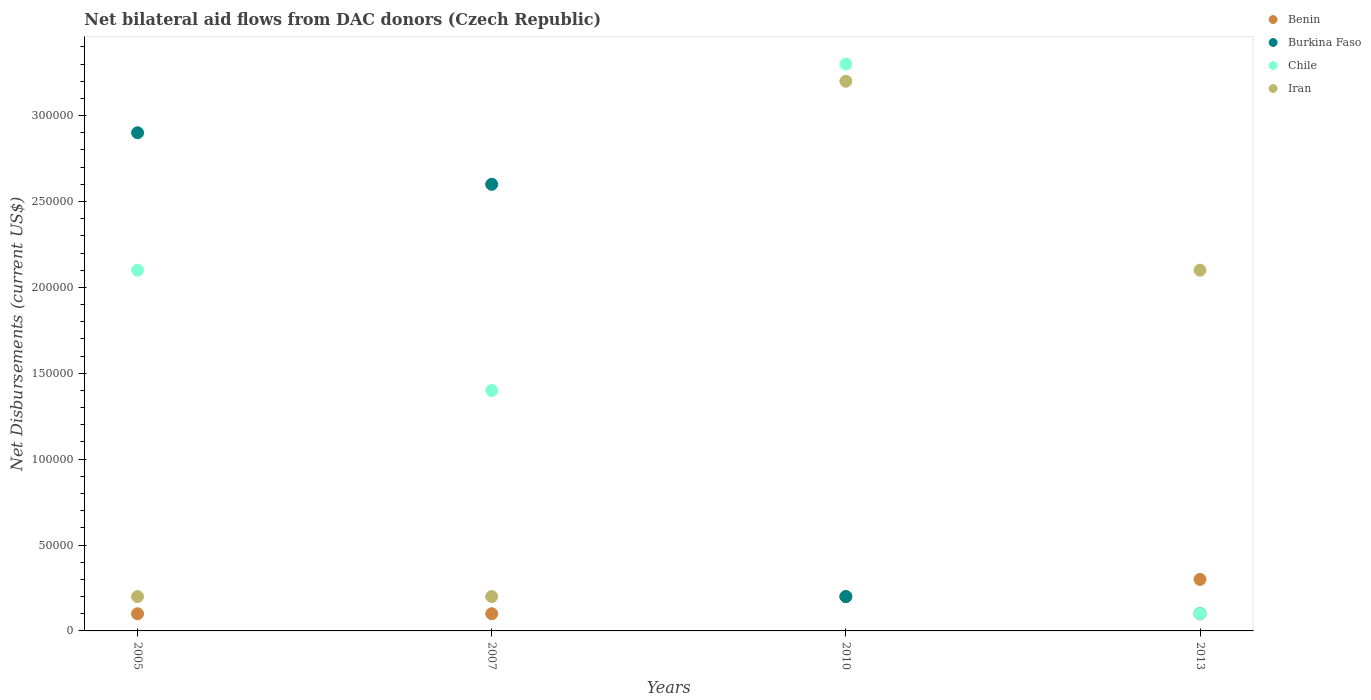How many different coloured dotlines are there?
Your answer should be compact. 4. Is the number of dotlines equal to the number of legend labels?
Keep it short and to the point. Yes. Across all years, what is the maximum net bilateral aid flows in Burkina Faso?
Offer a very short reply. 2.90e+05. Across all years, what is the minimum net bilateral aid flows in Iran?
Give a very brief answer. 2.00e+04. In which year was the net bilateral aid flows in Benin minimum?
Offer a terse response. 2005. What is the total net bilateral aid flows in Iran in the graph?
Your response must be concise. 5.70e+05. What is the difference between the net bilateral aid flows in Burkina Faso in 2013 and the net bilateral aid flows in Chile in 2005?
Ensure brevity in your answer.  -2.00e+05. What is the average net bilateral aid flows in Iran per year?
Your response must be concise. 1.42e+05. In the year 2005, what is the difference between the net bilateral aid flows in Iran and net bilateral aid flows in Burkina Faso?
Keep it short and to the point. -2.70e+05. What is the ratio of the net bilateral aid flows in Benin in 2007 to that in 2013?
Your response must be concise. 0.33. Is the net bilateral aid flows in Chile in 2005 less than that in 2007?
Make the answer very short. No. What is the difference between the highest and the second highest net bilateral aid flows in Iran?
Provide a short and direct response. 1.10e+05. In how many years, is the net bilateral aid flows in Chile greater than the average net bilateral aid flows in Chile taken over all years?
Your answer should be compact. 2. Is the sum of the net bilateral aid flows in Benin in 2007 and 2010 greater than the maximum net bilateral aid flows in Chile across all years?
Give a very brief answer. No. Is it the case that in every year, the sum of the net bilateral aid flows in Iran and net bilateral aid flows in Chile  is greater than the sum of net bilateral aid flows in Burkina Faso and net bilateral aid flows in Benin?
Give a very brief answer. No. Is the net bilateral aid flows in Benin strictly less than the net bilateral aid flows in Burkina Faso over the years?
Provide a succinct answer. No. How many years are there in the graph?
Provide a succinct answer. 4. What is the title of the graph?
Keep it short and to the point. Net bilateral aid flows from DAC donors (Czech Republic). What is the label or title of the Y-axis?
Provide a short and direct response. Net Disbursements (current US$). What is the Net Disbursements (current US$) in Burkina Faso in 2005?
Provide a short and direct response. 2.90e+05. What is the Net Disbursements (current US$) of Chile in 2005?
Provide a succinct answer. 2.10e+05. What is the Net Disbursements (current US$) of Benin in 2010?
Ensure brevity in your answer.  2.00e+04. What is the Net Disbursements (current US$) in Chile in 2010?
Keep it short and to the point. 3.30e+05. What is the Net Disbursements (current US$) in Iran in 2010?
Ensure brevity in your answer.  3.20e+05. What is the Net Disbursements (current US$) in Burkina Faso in 2013?
Offer a terse response. 10000. Across all years, what is the maximum Net Disbursements (current US$) in Iran?
Offer a terse response. 3.20e+05. Across all years, what is the minimum Net Disbursements (current US$) in Burkina Faso?
Offer a terse response. 10000. What is the total Net Disbursements (current US$) in Burkina Faso in the graph?
Make the answer very short. 5.80e+05. What is the total Net Disbursements (current US$) of Chile in the graph?
Your response must be concise. 6.90e+05. What is the total Net Disbursements (current US$) in Iran in the graph?
Give a very brief answer. 5.70e+05. What is the difference between the Net Disbursements (current US$) in Benin in 2005 and that in 2007?
Provide a succinct answer. 0. What is the difference between the Net Disbursements (current US$) in Chile in 2005 and that in 2007?
Provide a short and direct response. 7.00e+04. What is the difference between the Net Disbursements (current US$) in Benin in 2005 and that in 2010?
Keep it short and to the point. -10000. What is the difference between the Net Disbursements (current US$) in Iran in 2005 and that in 2010?
Your answer should be compact. -3.00e+05. What is the difference between the Net Disbursements (current US$) in Benin in 2005 and that in 2013?
Your answer should be compact. -2.00e+04. What is the difference between the Net Disbursements (current US$) of Iran in 2005 and that in 2013?
Give a very brief answer. -1.90e+05. What is the difference between the Net Disbursements (current US$) in Chile in 2007 and that in 2010?
Make the answer very short. -1.90e+05. What is the difference between the Net Disbursements (current US$) of Iran in 2007 and that in 2013?
Give a very brief answer. -1.90e+05. What is the difference between the Net Disbursements (current US$) of Benin in 2010 and that in 2013?
Your answer should be very brief. -10000. What is the difference between the Net Disbursements (current US$) in Chile in 2010 and that in 2013?
Provide a succinct answer. 3.20e+05. What is the difference between the Net Disbursements (current US$) of Iran in 2010 and that in 2013?
Give a very brief answer. 1.10e+05. What is the difference between the Net Disbursements (current US$) of Benin in 2005 and the Net Disbursements (current US$) of Burkina Faso in 2007?
Your response must be concise. -2.50e+05. What is the difference between the Net Disbursements (current US$) of Benin in 2005 and the Net Disbursements (current US$) of Chile in 2007?
Your answer should be very brief. -1.30e+05. What is the difference between the Net Disbursements (current US$) of Benin in 2005 and the Net Disbursements (current US$) of Iran in 2007?
Your answer should be very brief. -10000. What is the difference between the Net Disbursements (current US$) of Burkina Faso in 2005 and the Net Disbursements (current US$) of Iran in 2007?
Keep it short and to the point. 2.70e+05. What is the difference between the Net Disbursements (current US$) in Benin in 2005 and the Net Disbursements (current US$) in Chile in 2010?
Your answer should be very brief. -3.20e+05. What is the difference between the Net Disbursements (current US$) of Benin in 2005 and the Net Disbursements (current US$) of Iran in 2010?
Provide a short and direct response. -3.10e+05. What is the difference between the Net Disbursements (current US$) in Burkina Faso in 2005 and the Net Disbursements (current US$) in Iran in 2010?
Offer a very short reply. -3.00e+04. What is the difference between the Net Disbursements (current US$) of Benin in 2005 and the Net Disbursements (current US$) of Chile in 2013?
Your answer should be very brief. 0. What is the difference between the Net Disbursements (current US$) of Burkina Faso in 2005 and the Net Disbursements (current US$) of Iran in 2013?
Your answer should be compact. 8.00e+04. What is the difference between the Net Disbursements (current US$) of Chile in 2005 and the Net Disbursements (current US$) of Iran in 2013?
Your answer should be very brief. 0. What is the difference between the Net Disbursements (current US$) of Benin in 2007 and the Net Disbursements (current US$) of Chile in 2010?
Your response must be concise. -3.20e+05. What is the difference between the Net Disbursements (current US$) of Benin in 2007 and the Net Disbursements (current US$) of Iran in 2010?
Your response must be concise. -3.10e+05. What is the difference between the Net Disbursements (current US$) of Burkina Faso in 2007 and the Net Disbursements (current US$) of Chile in 2010?
Keep it short and to the point. -7.00e+04. What is the difference between the Net Disbursements (current US$) in Burkina Faso in 2007 and the Net Disbursements (current US$) in Iran in 2010?
Offer a terse response. -6.00e+04. What is the difference between the Net Disbursements (current US$) in Chile in 2007 and the Net Disbursements (current US$) in Iran in 2010?
Your answer should be very brief. -1.80e+05. What is the difference between the Net Disbursements (current US$) of Benin in 2007 and the Net Disbursements (current US$) of Chile in 2013?
Your answer should be compact. 0. What is the difference between the Net Disbursements (current US$) in Benin in 2007 and the Net Disbursements (current US$) in Iran in 2013?
Provide a short and direct response. -2.00e+05. What is the difference between the Net Disbursements (current US$) of Burkina Faso in 2007 and the Net Disbursements (current US$) of Chile in 2013?
Offer a terse response. 2.50e+05. What is the difference between the Net Disbursements (current US$) in Burkina Faso in 2007 and the Net Disbursements (current US$) in Iran in 2013?
Offer a terse response. 5.00e+04. What is the difference between the Net Disbursements (current US$) of Benin in 2010 and the Net Disbursements (current US$) of Chile in 2013?
Offer a terse response. 10000. What is the difference between the Net Disbursements (current US$) of Benin in 2010 and the Net Disbursements (current US$) of Iran in 2013?
Ensure brevity in your answer.  -1.90e+05. What is the average Net Disbursements (current US$) of Benin per year?
Offer a terse response. 1.75e+04. What is the average Net Disbursements (current US$) in Burkina Faso per year?
Keep it short and to the point. 1.45e+05. What is the average Net Disbursements (current US$) of Chile per year?
Keep it short and to the point. 1.72e+05. What is the average Net Disbursements (current US$) of Iran per year?
Your answer should be very brief. 1.42e+05. In the year 2005, what is the difference between the Net Disbursements (current US$) of Benin and Net Disbursements (current US$) of Burkina Faso?
Your answer should be very brief. -2.80e+05. In the year 2005, what is the difference between the Net Disbursements (current US$) of Benin and Net Disbursements (current US$) of Iran?
Provide a succinct answer. -10000. In the year 2005, what is the difference between the Net Disbursements (current US$) in Burkina Faso and Net Disbursements (current US$) in Iran?
Your response must be concise. 2.70e+05. In the year 2005, what is the difference between the Net Disbursements (current US$) in Chile and Net Disbursements (current US$) in Iran?
Your response must be concise. 1.90e+05. In the year 2007, what is the difference between the Net Disbursements (current US$) of Benin and Net Disbursements (current US$) of Iran?
Offer a terse response. -10000. In the year 2007, what is the difference between the Net Disbursements (current US$) of Burkina Faso and Net Disbursements (current US$) of Chile?
Your answer should be very brief. 1.20e+05. In the year 2007, what is the difference between the Net Disbursements (current US$) of Chile and Net Disbursements (current US$) of Iran?
Provide a succinct answer. 1.20e+05. In the year 2010, what is the difference between the Net Disbursements (current US$) of Benin and Net Disbursements (current US$) of Burkina Faso?
Offer a very short reply. 0. In the year 2010, what is the difference between the Net Disbursements (current US$) in Benin and Net Disbursements (current US$) in Chile?
Offer a terse response. -3.10e+05. In the year 2010, what is the difference between the Net Disbursements (current US$) in Benin and Net Disbursements (current US$) in Iran?
Your response must be concise. -3.00e+05. In the year 2010, what is the difference between the Net Disbursements (current US$) in Burkina Faso and Net Disbursements (current US$) in Chile?
Give a very brief answer. -3.10e+05. In the year 2010, what is the difference between the Net Disbursements (current US$) of Chile and Net Disbursements (current US$) of Iran?
Give a very brief answer. 10000. In the year 2013, what is the difference between the Net Disbursements (current US$) in Benin and Net Disbursements (current US$) in Burkina Faso?
Your answer should be compact. 2.00e+04. In the year 2013, what is the difference between the Net Disbursements (current US$) in Benin and Net Disbursements (current US$) in Chile?
Give a very brief answer. 2.00e+04. In the year 2013, what is the difference between the Net Disbursements (current US$) in Burkina Faso and Net Disbursements (current US$) in Chile?
Your answer should be compact. 0. In the year 2013, what is the difference between the Net Disbursements (current US$) of Chile and Net Disbursements (current US$) of Iran?
Keep it short and to the point. -2.00e+05. What is the ratio of the Net Disbursements (current US$) of Benin in 2005 to that in 2007?
Keep it short and to the point. 1. What is the ratio of the Net Disbursements (current US$) of Burkina Faso in 2005 to that in 2007?
Your response must be concise. 1.12. What is the ratio of the Net Disbursements (current US$) in Chile in 2005 to that in 2007?
Make the answer very short. 1.5. What is the ratio of the Net Disbursements (current US$) in Benin in 2005 to that in 2010?
Your response must be concise. 0.5. What is the ratio of the Net Disbursements (current US$) of Burkina Faso in 2005 to that in 2010?
Offer a terse response. 14.5. What is the ratio of the Net Disbursements (current US$) of Chile in 2005 to that in 2010?
Offer a very short reply. 0.64. What is the ratio of the Net Disbursements (current US$) in Iran in 2005 to that in 2010?
Give a very brief answer. 0.06. What is the ratio of the Net Disbursements (current US$) in Chile in 2005 to that in 2013?
Provide a short and direct response. 21. What is the ratio of the Net Disbursements (current US$) in Iran in 2005 to that in 2013?
Your answer should be very brief. 0.1. What is the ratio of the Net Disbursements (current US$) in Benin in 2007 to that in 2010?
Your answer should be very brief. 0.5. What is the ratio of the Net Disbursements (current US$) in Burkina Faso in 2007 to that in 2010?
Your answer should be compact. 13. What is the ratio of the Net Disbursements (current US$) in Chile in 2007 to that in 2010?
Your response must be concise. 0.42. What is the ratio of the Net Disbursements (current US$) of Iran in 2007 to that in 2010?
Make the answer very short. 0.06. What is the ratio of the Net Disbursements (current US$) in Benin in 2007 to that in 2013?
Give a very brief answer. 0.33. What is the ratio of the Net Disbursements (current US$) in Chile in 2007 to that in 2013?
Your response must be concise. 14. What is the ratio of the Net Disbursements (current US$) in Iran in 2007 to that in 2013?
Offer a very short reply. 0.1. What is the ratio of the Net Disbursements (current US$) of Iran in 2010 to that in 2013?
Keep it short and to the point. 1.52. What is the difference between the highest and the second highest Net Disbursements (current US$) of Chile?
Your answer should be compact. 1.20e+05. What is the difference between the highest and the second highest Net Disbursements (current US$) of Iran?
Your answer should be very brief. 1.10e+05. What is the difference between the highest and the lowest Net Disbursements (current US$) in Benin?
Keep it short and to the point. 2.00e+04. What is the difference between the highest and the lowest Net Disbursements (current US$) of Iran?
Your answer should be very brief. 3.00e+05. 